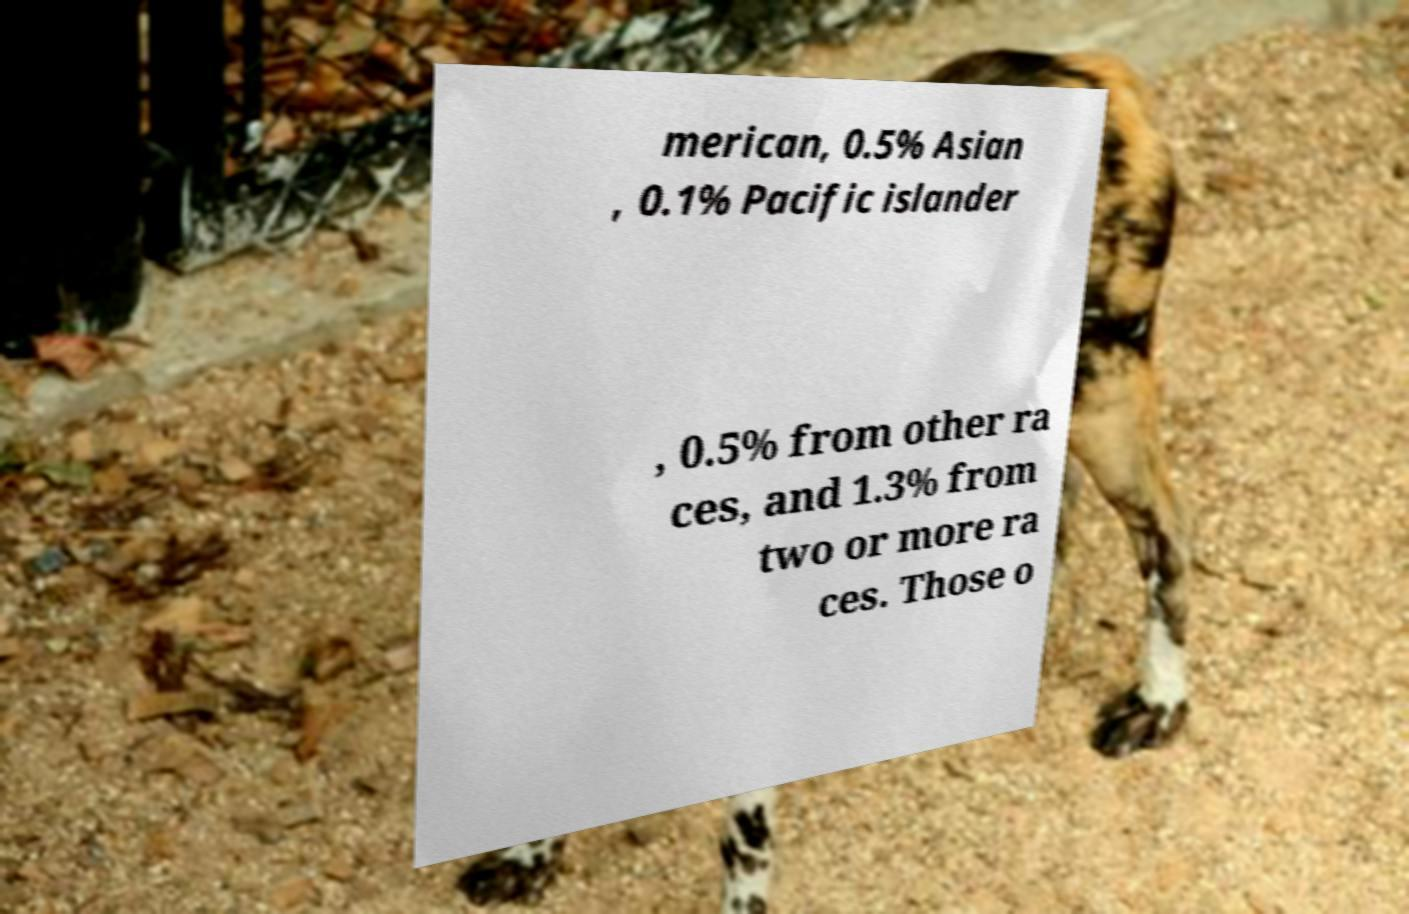What messages or text are displayed in this image? I need them in a readable, typed format. merican, 0.5% Asian , 0.1% Pacific islander , 0.5% from other ra ces, and 1.3% from two or more ra ces. Those o 